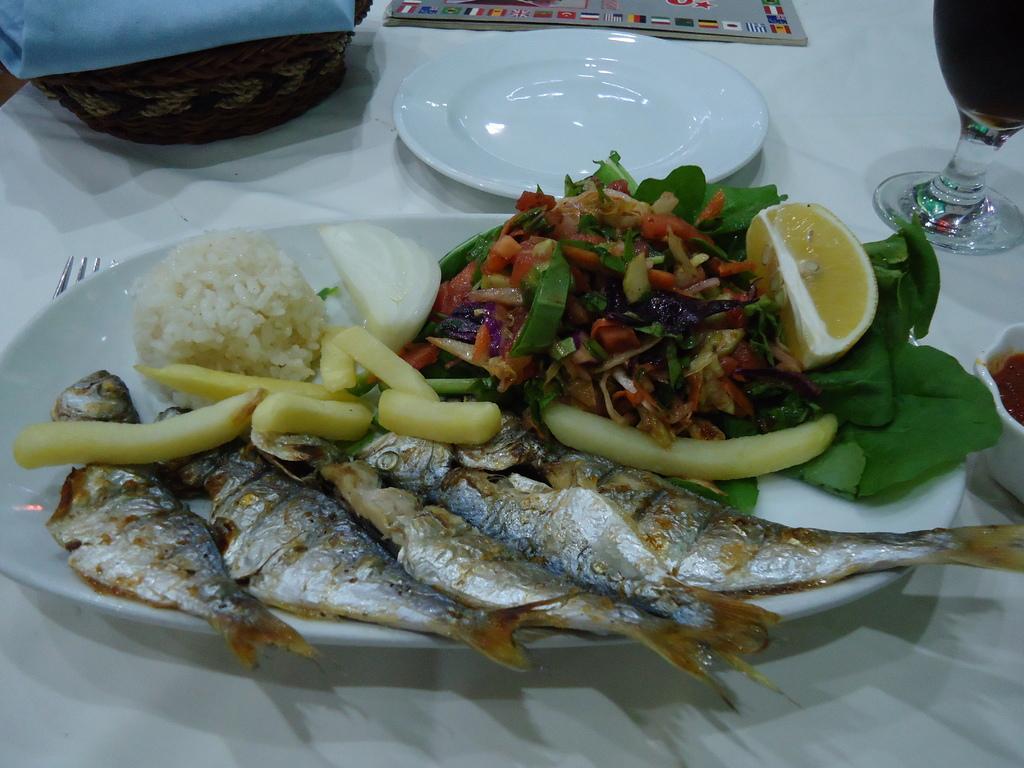Please provide a concise description of this image. In this image I can see a food plate, food contains fish, rice, lemon and fried vegetables. I can see a fork, another empty plate, a cup, a pamphlet, a wine glass, a basket with a cloth om the table. 